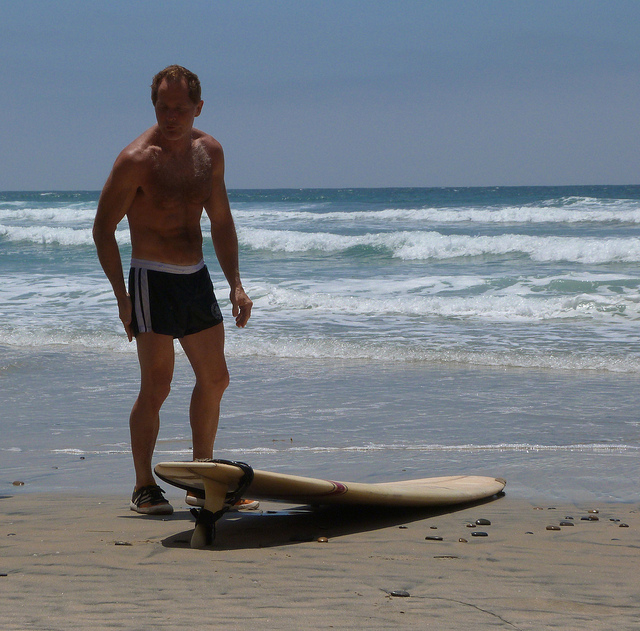Is the sea calm or turbulent? The sea appears to be moderately turbulent with visible waves rolling towards the shore, indicating active water movement but not extreme conditions. 